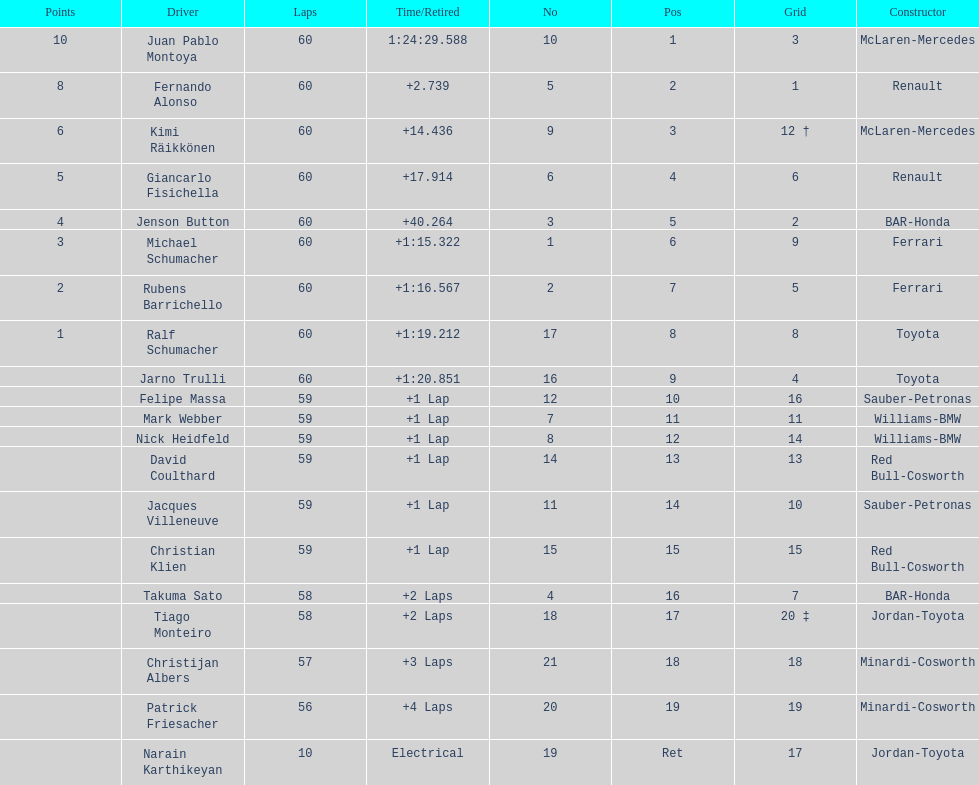How many drivers received points from the race? 8. 